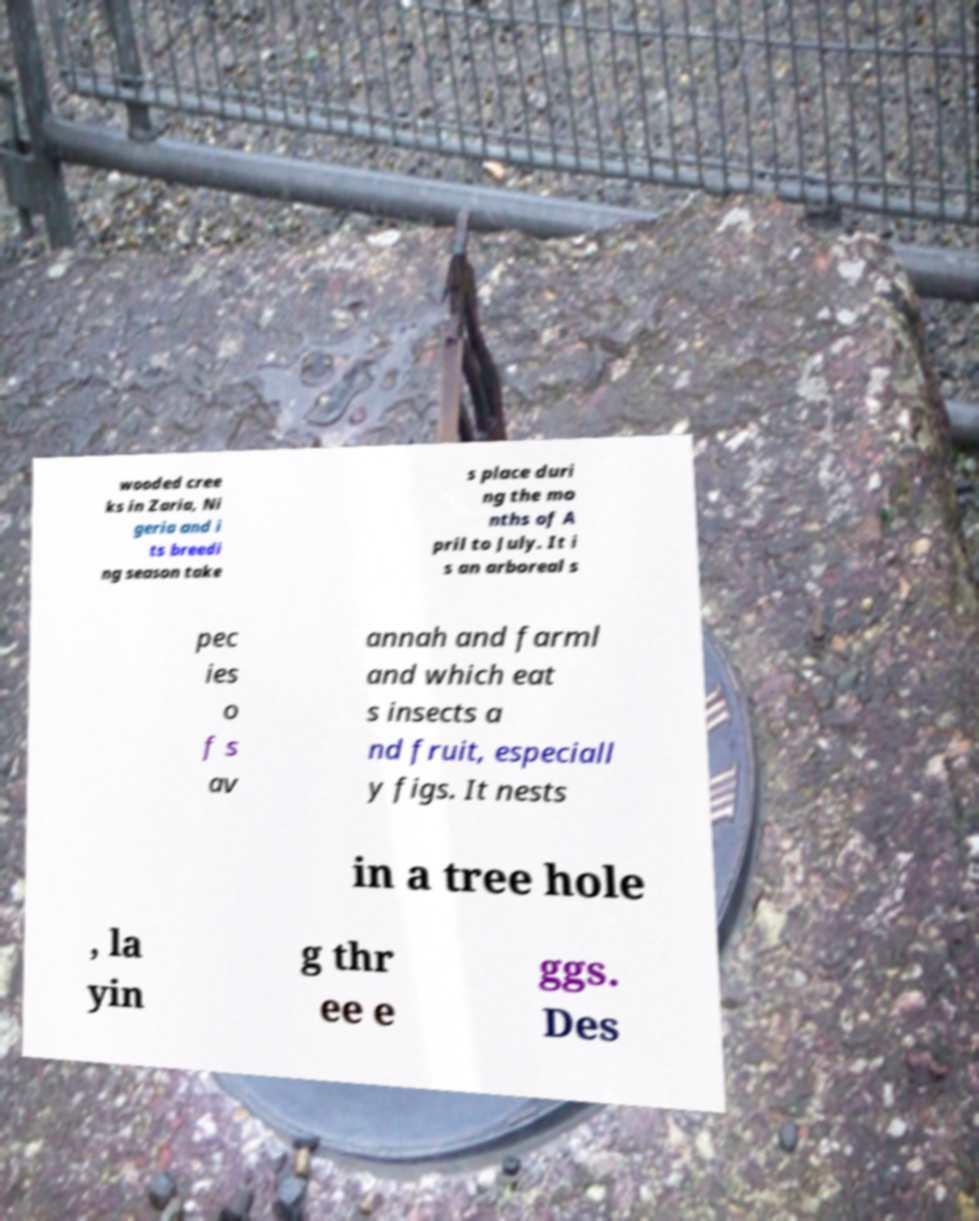Can you accurately transcribe the text from the provided image for me? wooded cree ks in Zaria, Ni geria and i ts breedi ng season take s place duri ng the mo nths of A pril to July. It i s an arboreal s pec ies o f s av annah and farml and which eat s insects a nd fruit, especiall y figs. It nests in a tree hole , la yin g thr ee e ggs. Des 